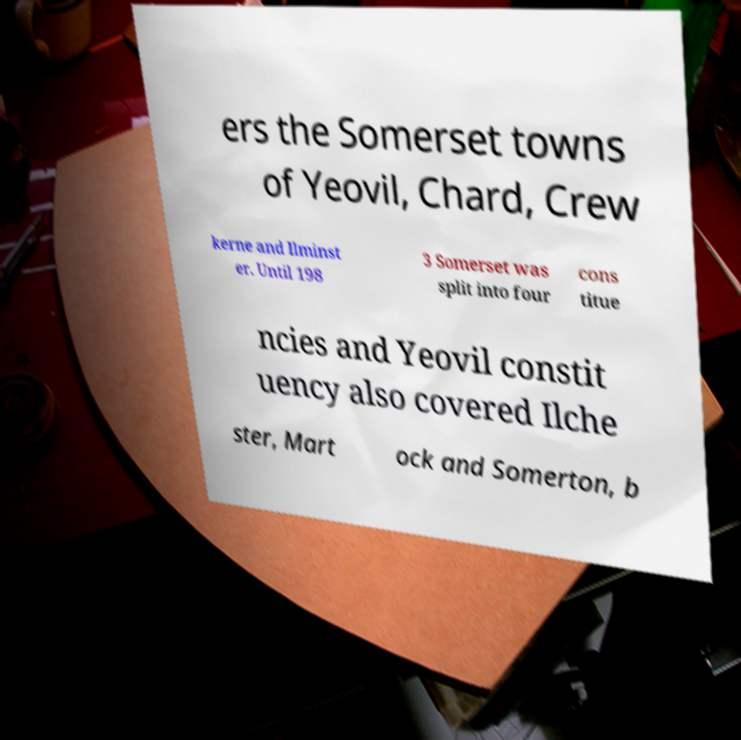Could you assist in decoding the text presented in this image and type it out clearly? ers the Somerset towns of Yeovil, Chard, Crew kerne and Ilminst er. Until 198 3 Somerset was split into four cons titue ncies and Yeovil constit uency also covered Ilche ster, Mart ock and Somerton, b 